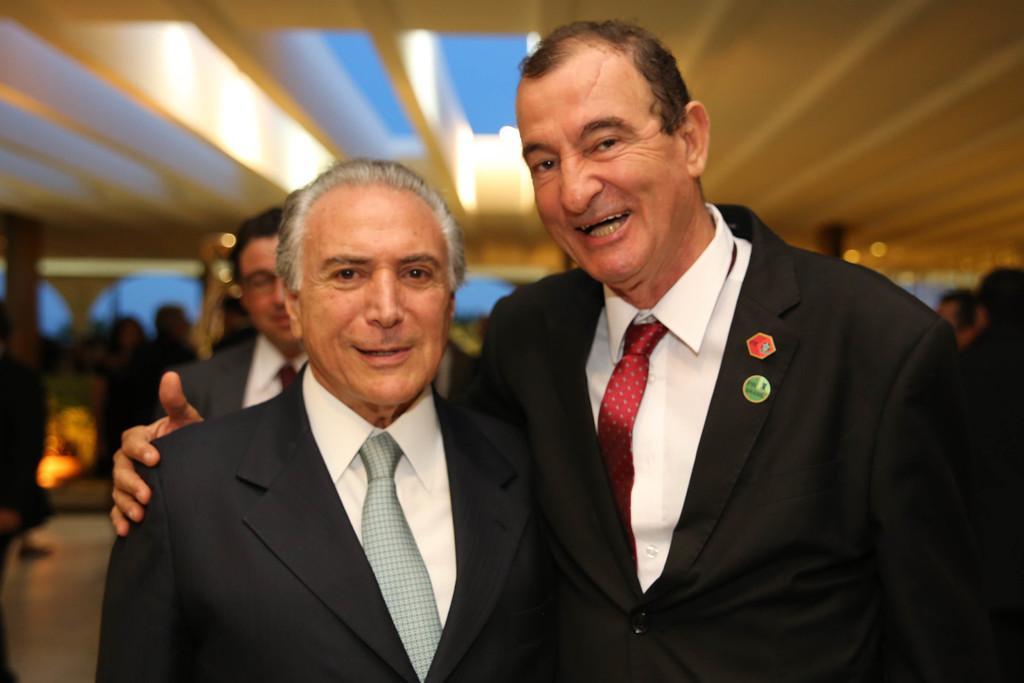Describe this image in one or two sentences. There are two men standing and wore suits,ties and shirts. Background we can see people and floor. 